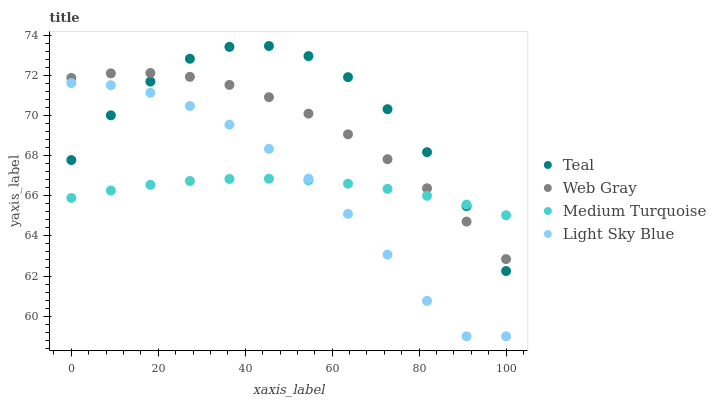Does Medium Turquoise have the minimum area under the curve?
Answer yes or no. Yes. Does Teal have the maximum area under the curve?
Answer yes or no. Yes. Does Teal have the minimum area under the curve?
Answer yes or no. No. Does Medium Turquoise have the maximum area under the curve?
Answer yes or no. No. Is Medium Turquoise the smoothest?
Answer yes or no. Yes. Is Teal the roughest?
Answer yes or no. Yes. Is Teal the smoothest?
Answer yes or no. No. Is Medium Turquoise the roughest?
Answer yes or no. No. Does Light Sky Blue have the lowest value?
Answer yes or no. Yes. Does Teal have the lowest value?
Answer yes or no. No. Does Teal have the highest value?
Answer yes or no. Yes. Does Medium Turquoise have the highest value?
Answer yes or no. No. Is Light Sky Blue less than Web Gray?
Answer yes or no. Yes. Is Web Gray greater than Light Sky Blue?
Answer yes or no. Yes. Does Light Sky Blue intersect Medium Turquoise?
Answer yes or no. Yes. Is Light Sky Blue less than Medium Turquoise?
Answer yes or no. No. Is Light Sky Blue greater than Medium Turquoise?
Answer yes or no. No. Does Light Sky Blue intersect Web Gray?
Answer yes or no. No. 